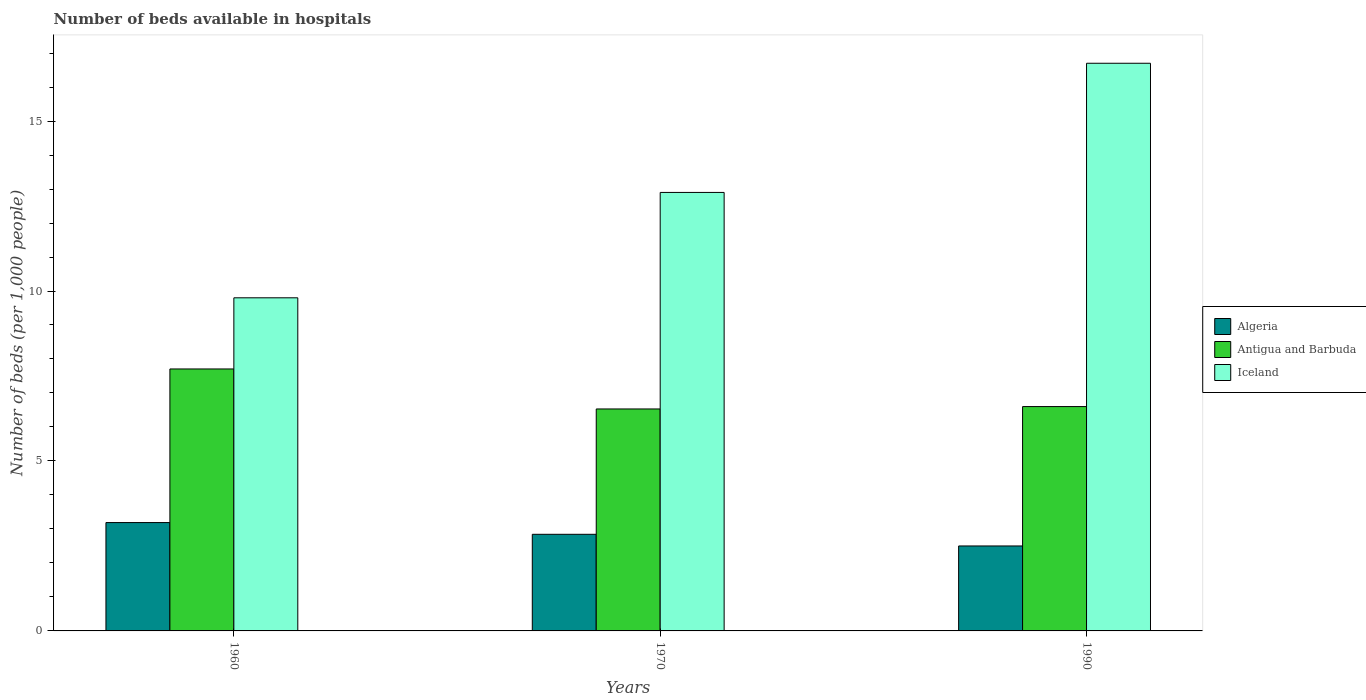How many different coloured bars are there?
Your response must be concise. 3. Are the number of bars per tick equal to the number of legend labels?
Your answer should be compact. Yes. In how many cases, is the number of bars for a given year not equal to the number of legend labels?
Your answer should be compact. 0. What is the number of beds in the hospiatls of in Iceland in 1970?
Give a very brief answer. 12.9. Across all years, what is the maximum number of beds in the hospiatls of in Algeria?
Provide a succinct answer. 3.19. Across all years, what is the minimum number of beds in the hospiatls of in Algeria?
Your answer should be compact. 2.5. In which year was the number of beds in the hospiatls of in Iceland maximum?
Your answer should be compact. 1990. In which year was the number of beds in the hospiatls of in Algeria minimum?
Offer a terse response. 1990. What is the total number of beds in the hospiatls of in Iceland in the graph?
Your answer should be compact. 39.4. What is the difference between the number of beds in the hospiatls of in Algeria in 1970 and that in 1990?
Your response must be concise. 0.34. What is the difference between the number of beds in the hospiatls of in Iceland in 1970 and the number of beds in the hospiatls of in Algeria in 1990?
Offer a very short reply. 10.4. What is the average number of beds in the hospiatls of in Algeria per year?
Provide a succinct answer. 2.84. In the year 1960, what is the difference between the number of beds in the hospiatls of in Antigua and Barbuda and number of beds in the hospiatls of in Iceland?
Ensure brevity in your answer.  -2.09. In how many years, is the number of beds in the hospiatls of in Iceland greater than 6?
Offer a terse response. 3. What is the ratio of the number of beds in the hospiatls of in Iceland in 1970 to that in 1990?
Keep it short and to the point. 0.77. Is the number of beds in the hospiatls of in Algeria in 1960 less than that in 1990?
Make the answer very short. No. Is the difference between the number of beds in the hospiatls of in Antigua and Barbuda in 1960 and 1990 greater than the difference between the number of beds in the hospiatls of in Iceland in 1960 and 1990?
Provide a short and direct response. Yes. What is the difference between the highest and the second highest number of beds in the hospiatls of in Antigua and Barbuda?
Ensure brevity in your answer.  1.11. What is the difference between the highest and the lowest number of beds in the hospiatls of in Algeria?
Offer a very short reply. 0.69. In how many years, is the number of beds in the hospiatls of in Antigua and Barbuda greater than the average number of beds in the hospiatls of in Antigua and Barbuda taken over all years?
Ensure brevity in your answer.  1. Is the sum of the number of beds in the hospiatls of in Algeria in 1960 and 1970 greater than the maximum number of beds in the hospiatls of in Iceland across all years?
Provide a succinct answer. No. What does the 1st bar from the left in 1970 represents?
Ensure brevity in your answer.  Algeria. What does the 2nd bar from the right in 1960 represents?
Your response must be concise. Antigua and Barbuda. How many bars are there?
Provide a short and direct response. 9. Where does the legend appear in the graph?
Ensure brevity in your answer.  Center right. How many legend labels are there?
Offer a terse response. 3. What is the title of the graph?
Provide a succinct answer. Number of beds available in hospitals. What is the label or title of the Y-axis?
Offer a terse response. Number of beds (per 1,0 people). What is the Number of beds (per 1,000 people) of Algeria in 1960?
Your response must be concise. 3.19. What is the Number of beds (per 1,000 people) in Antigua and Barbuda in 1960?
Give a very brief answer. 7.71. What is the Number of beds (per 1,000 people) of Iceland in 1960?
Ensure brevity in your answer.  9.8. What is the Number of beds (per 1,000 people) of Algeria in 1970?
Provide a succinct answer. 2.84. What is the Number of beds (per 1,000 people) of Antigua and Barbuda in 1970?
Provide a short and direct response. 6.53. What is the Number of beds (per 1,000 people) of Iceland in 1970?
Provide a short and direct response. 12.9. What is the Number of beds (per 1,000 people) of Algeria in 1990?
Provide a succinct answer. 2.5. What is the Number of beds (per 1,000 people) in Antigua and Barbuda in 1990?
Provide a succinct answer. 6.6. What is the Number of beds (per 1,000 people) of Iceland in 1990?
Your answer should be compact. 16.7. Across all years, what is the maximum Number of beds (per 1,000 people) in Algeria?
Keep it short and to the point. 3.19. Across all years, what is the maximum Number of beds (per 1,000 people) of Antigua and Barbuda?
Your answer should be compact. 7.71. Across all years, what is the maximum Number of beds (per 1,000 people) of Iceland?
Make the answer very short. 16.7. Across all years, what is the minimum Number of beds (per 1,000 people) of Algeria?
Keep it short and to the point. 2.5. Across all years, what is the minimum Number of beds (per 1,000 people) in Antigua and Barbuda?
Your response must be concise. 6.53. Across all years, what is the minimum Number of beds (per 1,000 people) in Iceland?
Your response must be concise. 9.8. What is the total Number of beds (per 1,000 people) of Algeria in the graph?
Provide a short and direct response. 8.53. What is the total Number of beds (per 1,000 people) in Antigua and Barbuda in the graph?
Keep it short and to the point. 20.84. What is the total Number of beds (per 1,000 people) of Iceland in the graph?
Keep it short and to the point. 39.4. What is the difference between the Number of beds (per 1,000 people) of Algeria in 1960 and that in 1970?
Give a very brief answer. 0.34. What is the difference between the Number of beds (per 1,000 people) of Antigua and Barbuda in 1960 and that in 1970?
Offer a terse response. 1.18. What is the difference between the Number of beds (per 1,000 people) in Algeria in 1960 and that in 1990?
Give a very brief answer. 0.69. What is the difference between the Number of beds (per 1,000 people) in Antigua and Barbuda in 1960 and that in 1990?
Your answer should be very brief. 1.11. What is the difference between the Number of beds (per 1,000 people) of Algeria in 1970 and that in 1990?
Provide a succinct answer. 0.34. What is the difference between the Number of beds (per 1,000 people) in Antigua and Barbuda in 1970 and that in 1990?
Make the answer very short. -0.07. What is the difference between the Number of beds (per 1,000 people) of Algeria in 1960 and the Number of beds (per 1,000 people) of Antigua and Barbuda in 1970?
Make the answer very short. -3.34. What is the difference between the Number of beds (per 1,000 people) in Algeria in 1960 and the Number of beds (per 1,000 people) in Iceland in 1970?
Your response must be concise. -9.71. What is the difference between the Number of beds (per 1,000 people) in Antigua and Barbuda in 1960 and the Number of beds (per 1,000 people) in Iceland in 1970?
Provide a short and direct response. -5.19. What is the difference between the Number of beds (per 1,000 people) of Algeria in 1960 and the Number of beds (per 1,000 people) of Antigua and Barbuda in 1990?
Your response must be concise. -3.41. What is the difference between the Number of beds (per 1,000 people) in Algeria in 1960 and the Number of beds (per 1,000 people) in Iceland in 1990?
Your response must be concise. -13.51. What is the difference between the Number of beds (per 1,000 people) of Antigua and Barbuda in 1960 and the Number of beds (per 1,000 people) of Iceland in 1990?
Offer a terse response. -8.99. What is the difference between the Number of beds (per 1,000 people) in Algeria in 1970 and the Number of beds (per 1,000 people) in Antigua and Barbuda in 1990?
Provide a succinct answer. -3.76. What is the difference between the Number of beds (per 1,000 people) of Algeria in 1970 and the Number of beds (per 1,000 people) of Iceland in 1990?
Offer a very short reply. -13.86. What is the difference between the Number of beds (per 1,000 people) of Antigua and Barbuda in 1970 and the Number of beds (per 1,000 people) of Iceland in 1990?
Provide a short and direct response. -10.17. What is the average Number of beds (per 1,000 people) of Algeria per year?
Give a very brief answer. 2.84. What is the average Number of beds (per 1,000 people) of Antigua and Barbuda per year?
Your answer should be very brief. 6.95. What is the average Number of beds (per 1,000 people) in Iceland per year?
Offer a terse response. 13.13. In the year 1960, what is the difference between the Number of beds (per 1,000 people) in Algeria and Number of beds (per 1,000 people) in Antigua and Barbuda?
Offer a terse response. -4.52. In the year 1960, what is the difference between the Number of beds (per 1,000 people) of Algeria and Number of beds (per 1,000 people) of Iceland?
Your answer should be compact. -6.61. In the year 1960, what is the difference between the Number of beds (per 1,000 people) in Antigua and Barbuda and Number of beds (per 1,000 people) in Iceland?
Offer a very short reply. -2.09. In the year 1970, what is the difference between the Number of beds (per 1,000 people) in Algeria and Number of beds (per 1,000 people) in Antigua and Barbuda?
Your response must be concise. -3.69. In the year 1970, what is the difference between the Number of beds (per 1,000 people) in Algeria and Number of beds (per 1,000 people) in Iceland?
Offer a terse response. -10.06. In the year 1970, what is the difference between the Number of beds (per 1,000 people) of Antigua and Barbuda and Number of beds (per 1,000 people) of Iceland?
Your answer should be compact. -6.37. In the year 1990, what is the difference between the Number of beds (per 1,000 people) of Algeria and Number of beds (per 1,000 people) of Antigua and Barbuda?
Make the answer very short. -4.1. In the year 1990, what is the difference between the Number of beds (per 1,000 people) in Algeria and Number of beds (per 1,000 people) in Iceland?
Your response must be concise. -14.2. In the year 1990, what is the difference between the Number of beds (per 1,000 people) in Antigua and Barbuda and Number of beds (per 1,000 people) in Iceland?
Provide a succinct answer. -10.1. What is the ratio of the Number of beds (per 1,000 people) of Algeria in 1960 to that in 1970?
Provide a succinct answer. 1.12. What is the ratio of the Number of beds (per 1,000 people) in Antigua and Barbuda in 1960 to that in 1970?
Make the answer very short. 1.18. What is the ratio of the Number of beds (per 1,000 people) of Iceland in 1960 to that in 1970?
Your response must be concise. 0.76. What is the ratio of the Number of beds (per 1,000 people) of Algeria in 1960 to that in 1990?
Your answer should be very brief. 1.28. What is the ratio of the Number of beds (per 1,000 people) of Antigua and Barbuda in 1960 to that in 1990?
Your response must be concise. 1.17. What is the ratio of the Number of beds (per 1,000 people) of Iceland in 1960 to that in 1990?
Provide a succinct answer. 0.59. What is the ratio of the Number of beds (per 1,000 people) of Algeria in 1970 to that in 1990?
Make the answer very short. 1.14. What is the ratio of the Number of beds (per 1,000 people) of Iceland in 1970 to that in 1990?
Offer a terse response. 0.77. What is the difference between the highest and the second highest Number of beds (per 1,000 people) in Algeria?
Your answer should be very brief. 0.34. What is the difference between the highest and the second highest Number of beds (per 1,000 people) of Antigua and Barbuda?
Give a very brief answer. 1.11. What is the difference between the highest and the second highest Number of beds (per 1,000 people) of Iceland?
Give a very brief answer. 3.8. What is the difference between the highest and the lowest Number of beds (per 1,000 people) of Algeria?
Offer a terse response. 0.69. What is the difference between the highest and the lowest Number of beds (per 1,000 people) in Antigua and Barbuda?
Offer a very short reply. 1.18. 